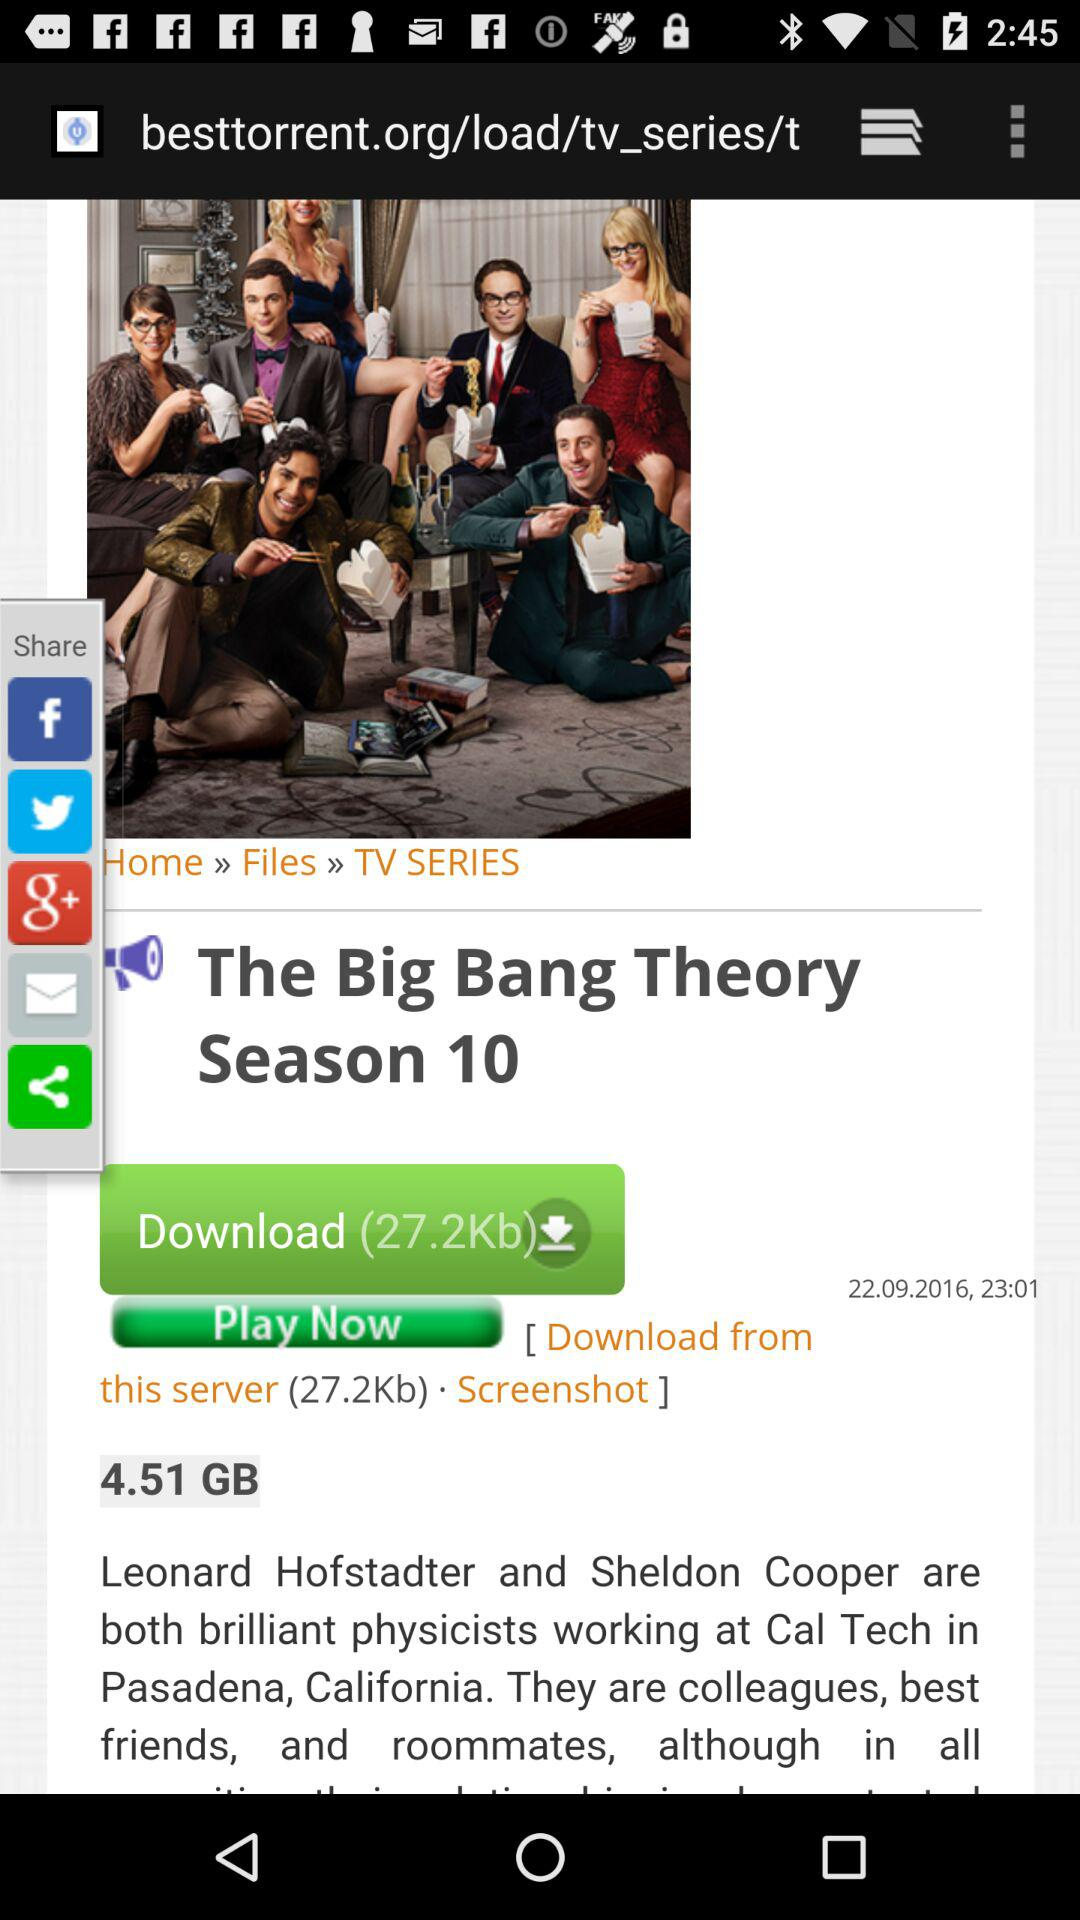Through which application can it be shared? It can be shared through "Facebook", "Twitter" and "Google+". 